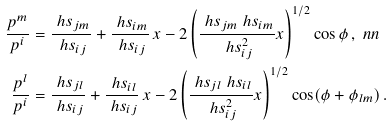<formula> <loc_0><loc_0><loc_500><loc_500>\frac { p ^ { m } } { p ^ { i } } & = \frac { \ h s _ { j m } } { \ h s _ { i j } } + \frac { \ h s _ { i m } } { \ h s _ { i j } } \, x - 2 \left ( \frac { \ h s _ { j m } \ h s _ { i m } } { \ h s _ { i j } ^ { 2 } } x \right ) ^ { 1 / 2 } \cos \phi \, , \ n n \\ \frac { p ^ { l } } { p ^ { i } } & = \frac { \ h s _ { j l } } { \ h s _ { i j } } + \frac { \ h s _ { i l } } { \ h s _ { i j } } \, x - 2 \left ( \frac { \ h s _ { j l } \ h s _ { i l } } { \ h s _ { i j } ^ { 2 } } x \right ) ^ { 1 / 2 } \cos ( \phi + \phi _ { l m } ) \, .</formula> 